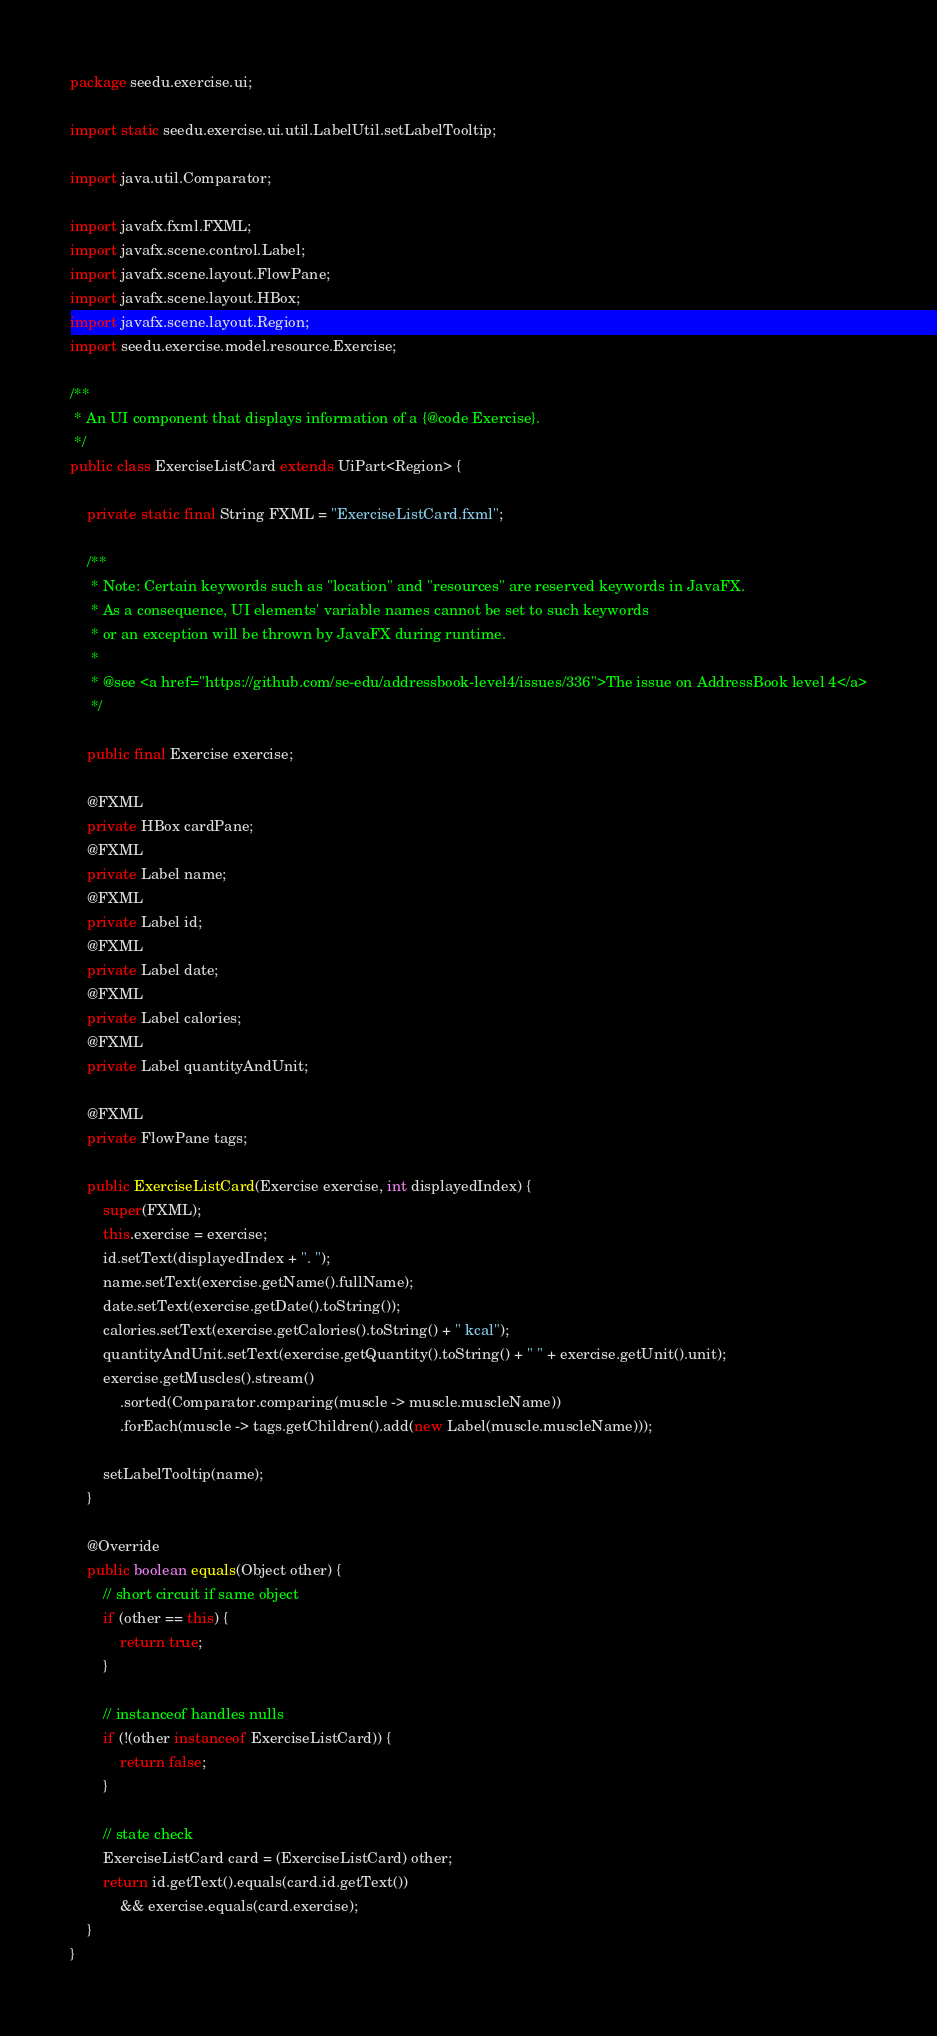Convert code to text. <code><loc_0><loc_0><loc_500><loc_500><_Java_>package seedu.exercise.ui;

import static seedu.exercise.ui.util.LabelUtil.setLabelTooltip;

import java.util.Comparator;

import javafx.fxml.FXML;
import javafx.scene.control.Label;
import javafx.scene.layout.FlowPane;
import javafx.scene.layout.HBox;
import javafx.scene.layout.Region;
import seedu.exercise.model.resource.Exercise;

/**
 * An UI component that displays information of a {@code Exercise}.
 */
public class ExerciseListCard extends UiPart<Region> {

    private static final String FXML = "ExerciseListCard.fxml";

    /**
     * Note: Certain keywords such as "location" and "resources" are reserved keywords in JavaFX.
     * As a consequence, UI elements' variable names cannot be set to such keywords
     * or an exception will be thrown by JavaFX during runtime.
     *
     * @see <a href="https://github.com/se-edu/addressbook-level4/issues/336">The issue on AddressBook level 4</a>
     */

    public final Exercise exercise;

    @FXML
    private HBox cardPane;
    @FXML
    private Label name;
    @FXML
    private Label id;
    @FXML
    private Label date;
    @FXML
    private Label calories;
    @FXML
    private Label quantityAndUnit;

    @FXML
    private FlowPane tags;

    public ExerciseListCard(Exercise exercise, int displayedIndex) {
        super(FXML);
        this.exercise = exercise;
        id.setText(displayedIndex + ". ");
        name.setText(exercise.getName().fullName);
        date.setText(exercise.getDate().toString());
        calories.setText(exercise.getCalories().toString() + " kcal");
        quantityAndUnit.setText(exercise.getQuantity().toString() + " " + exercise.getUnit().unit);
        exercise.getMuscles().stream()
            .sorted(Comparator.comparing(muscle -> muscle.muscleName))
            .forEach(muscle -> tags.getChildren().add(new Label(muscle.muscleName)));

        setLabelTooltip(name);
    }

    @Override
    public boolean equals(Object other) {
        // short circuit if same object
        if (other == this) {
            return true;
        }

        // instanceof handles nulls
        if (!(other instanceof ExerciseListCard)) {
            return false;
        }

        // state check
        ExerciseListCard card = (ExerciseListCard) other;
        return id.getText().equals(card.id.getText())
            && exercise.equals(card.exercise);
    }
}
</code> 